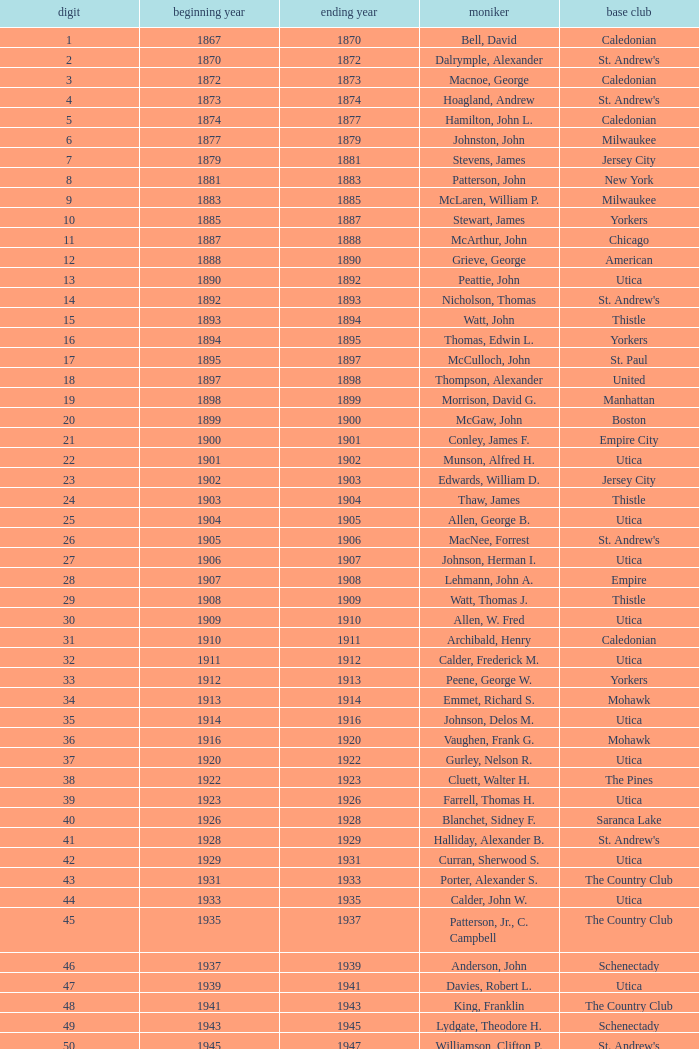Which Number has a Name of hill, lucius t.? 53.0. 